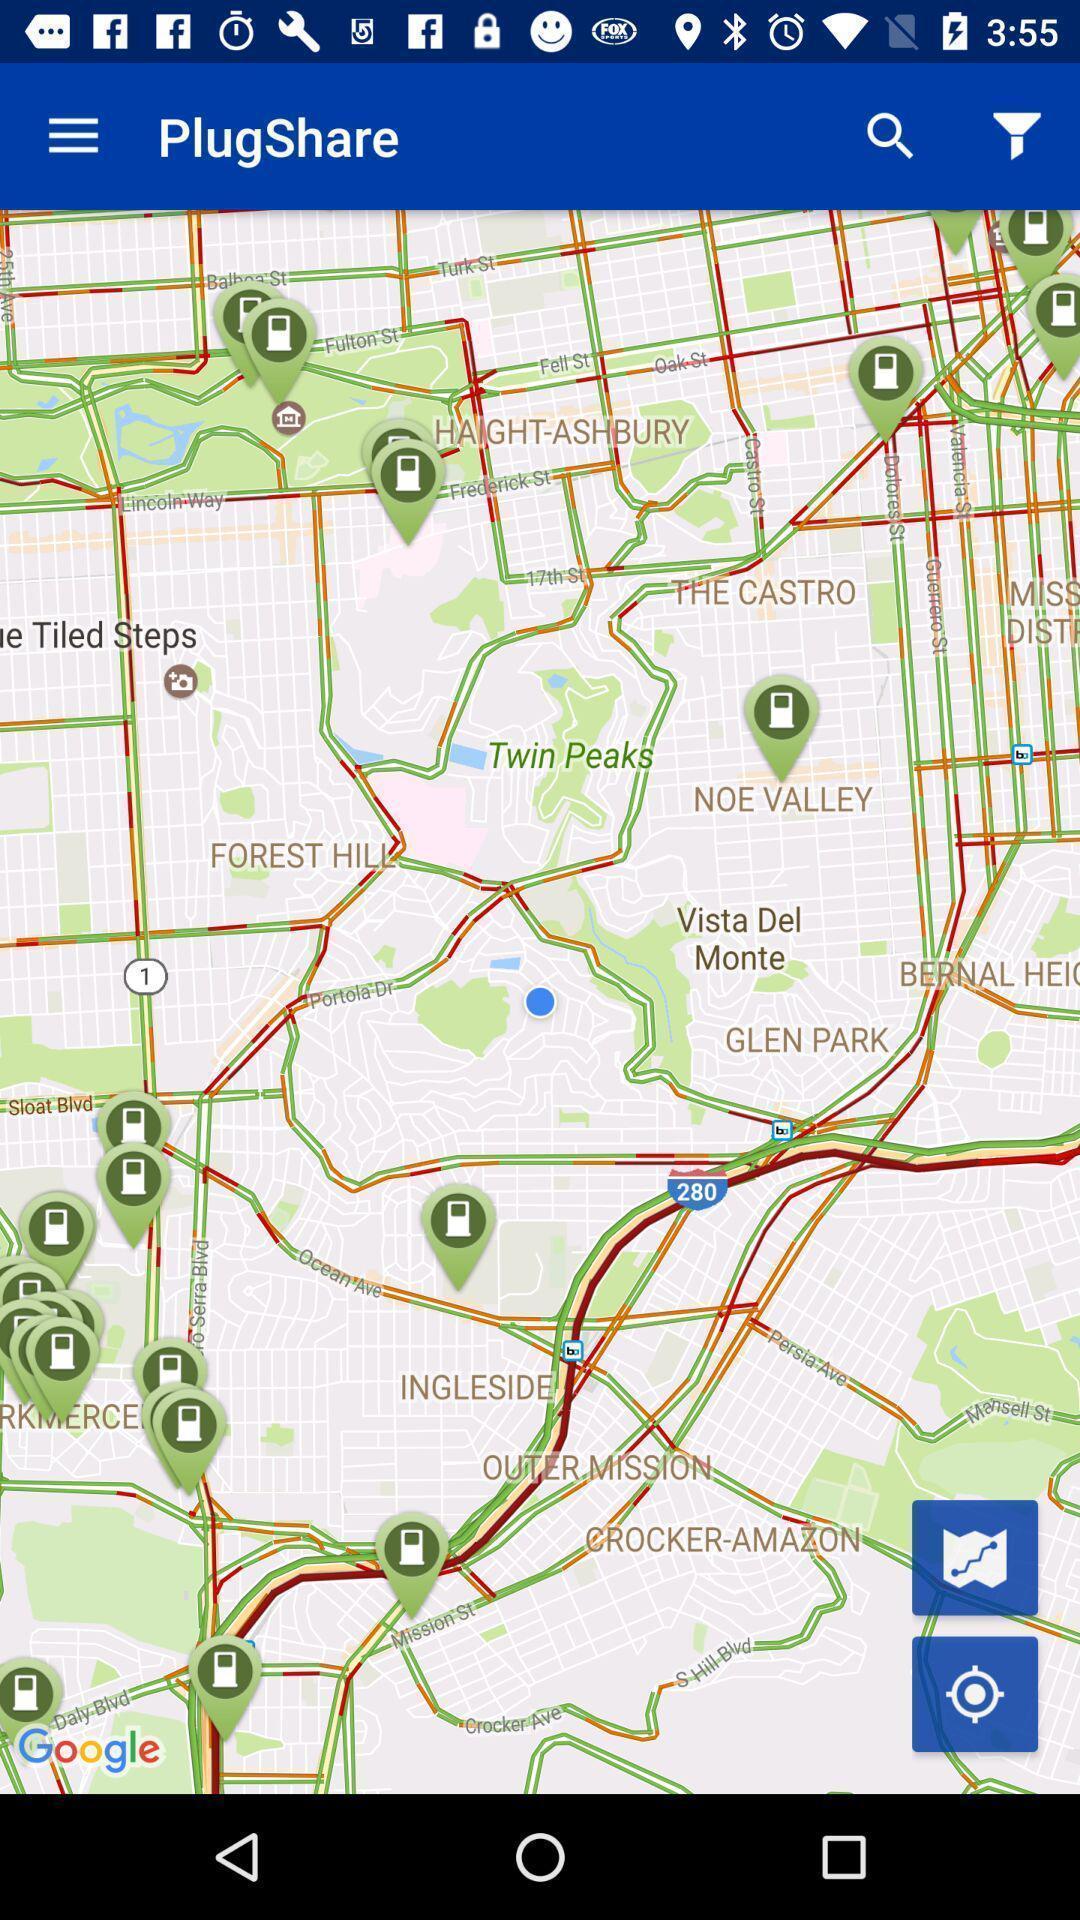Give me a summary of this screen capture. Page showing google map with different address. 